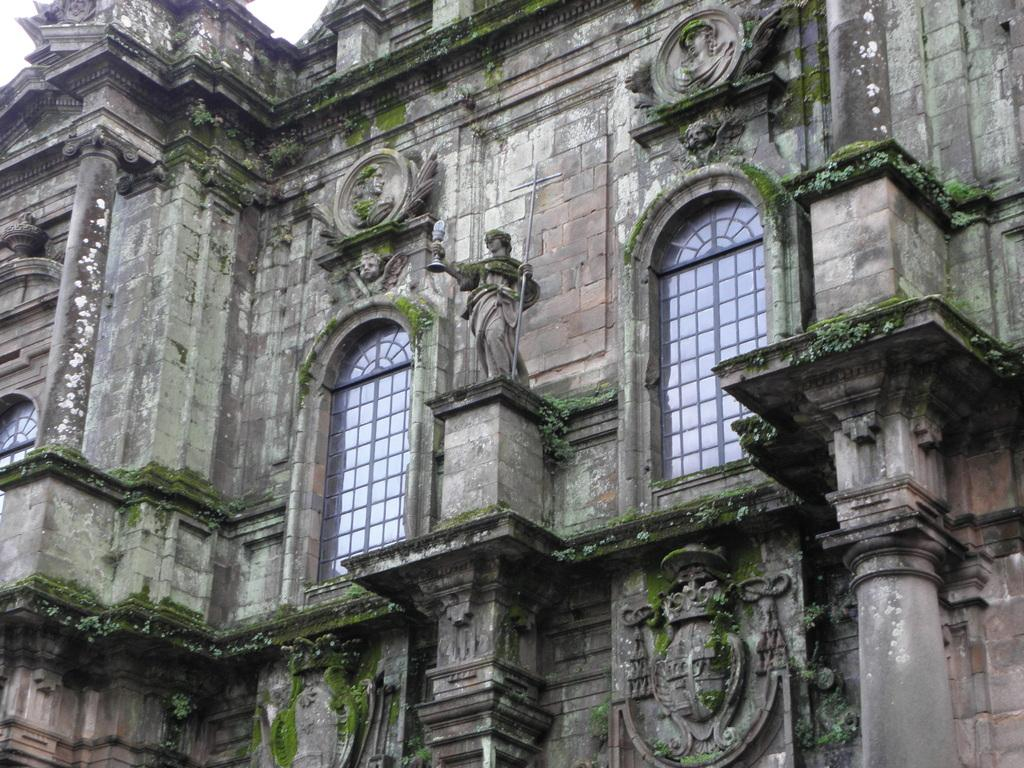What is the main structure in the picture? There is a palace in the picture. What type of windows does the palace have? The palace has glass windows. Can you see a window in the picture? There is no mention of a "window" in the provided facts. The palace has glass windows, but there is no specific window mentioned. --- Facts: 1. There is a car in the image. 2. The car is red. 3. The car has four wheels. 4. The car is parked on the street. 5. There are people walking on the street. Absurd Topics: bicycle Conversation: What is the main object in the image? There is a car in the image. What is the color of the car? The car is red. How many wheels does the car have? The car has four wheels. Where is the car located in the image? The car is parked on the street. What else can be seen in the image? There are people walking on the street. Reasoning: Let's think step by step in order to produce the conversation. We start by identifying the main subject of the image, which is the car. Next, we describe specific features of the car, such as the color and the number of wheels. Then, we observe the actions of the people in the image, noting that they are walking on the street. Finally, we describe the location of the car in the image, which is parked on the street. Absurd Question/Answer: How many bicycles can be seen in the image? There is no mention of bicycles in the provided facts. --- Facts: 1. There is a group of people in the image. 2. The people are wearing hats. 3. The people are holding hands. 4. The people are standing in front of a building. 5. The building has a large sign on its facade. Absurd Topics: elephant Conversation: How many people are in the image? There is a group of people in the image. What are the people wearing on their heads? The people are wearing hats. What are the people doing in the image? The people are holding hands. Where are the people standing in the image? The people are standing in front of a building. What can be seen on the building in the image? The building has a large sign on its facade. Reasoning: Let's think step by step in order to produce the conversation. We start by identifying the main subject of the image, which is the group of people. Next, we describe specific features of the people, such as the type of hats they are wearing. Then, we observe the actions of the people in the image, noting that they are holding hands. Finally, we describe the location of the people in the image, which is in front of a building. Absurd Question/Answer: Q: 